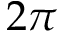<formula> <loc_0><loc_0><loc_500><loc_500>2 \pi</formula> 